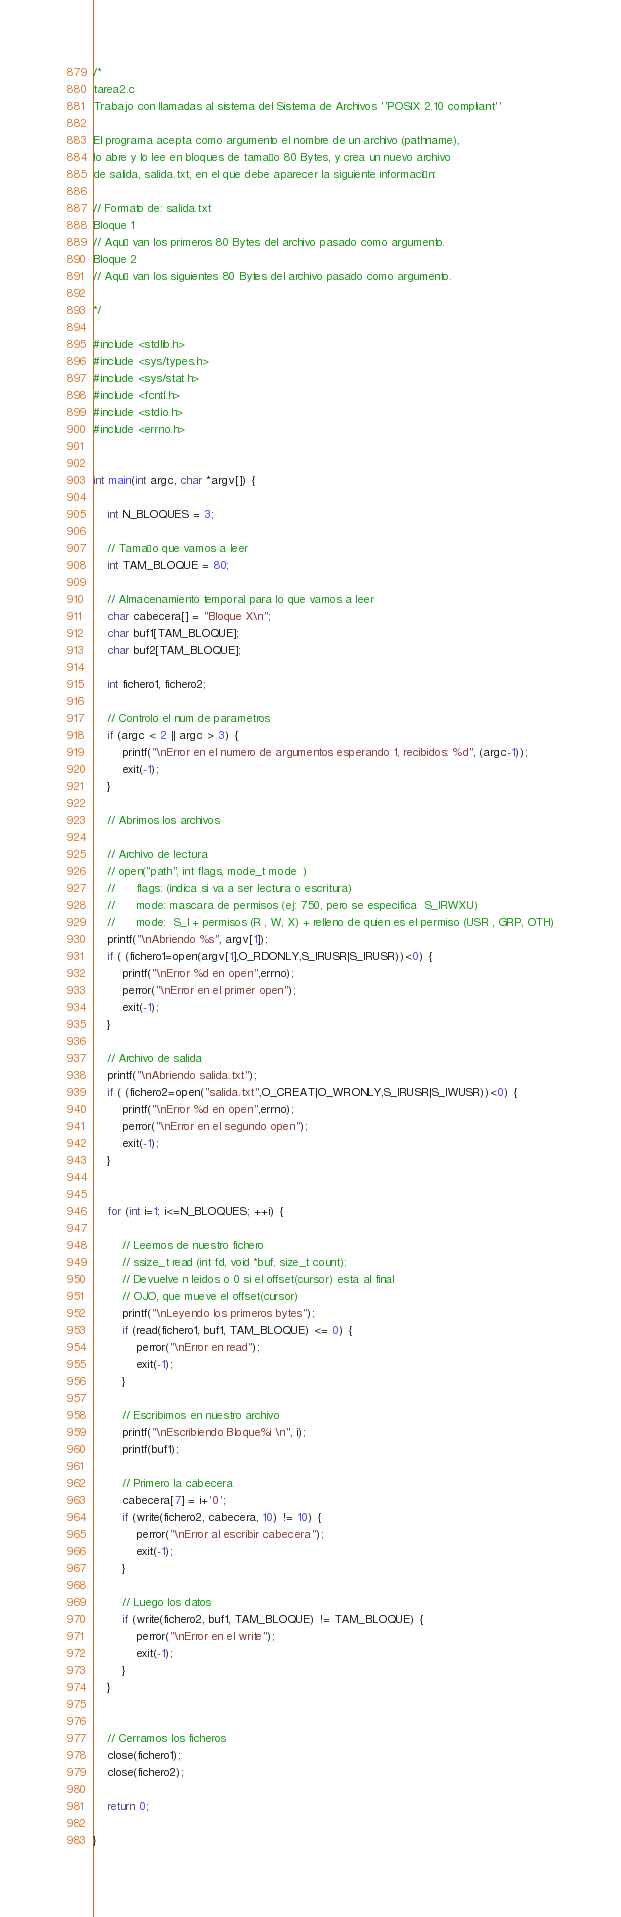<code> <loc_0><loc_0><loc_500><loc_500><_C_>/*
tarea2.c
Trabajo con llamadas al sistema del Sistema de Archivos ''POSIX 2.10 compliant''

El programa acepta como argumento el nombre de un archivo (pathname), 
lo abre y lo lee en bloques de tamaño 80 Bytes, y crea un nuevo archivo 
de salida, salida.txt, en el que debe aparecer la siguiente información:

// Formato de: salida.txt 
Bloque 1
// Aquí van los primeros 80 Bytes del archivo pasado como argumento.
Bloque 2
// Aquí van los siguientes 80 Bytes del archivo pasado como argumento.

*/

#include <stdlib.h>
#include <sys/types.h>
#include <sys/stat.h>
#include <fcntl.h>
#include <stdio.h>
#include <errno.h>


int main(int argc, char *argv[]) {
	
	int N_BLOQUES = 3;

	// Tamaño que vamos a leer
	int TAM_BLOQUE = 80;

	// Almacenamiento temporal para lo que vamos a leer
	char cabecera[] = "Bloque X\n";
	char buf1[TAM_BLOQUE];
	char buf2[TAM_BLOQUE];

	int fichero1, fichero2;

	// Controlo el num de parametros
	if (argc < 2 || argc > 3) {
		printf("\nError en el numero de argumentos esperando 1, recibidos: %d", (argc-1));
		exit(-1);
	}

	// Abrimos los archivos

	// Archivo de lectura 
	// open("path", int flags, mode_t mode  )
	// 		flags: (indica si va a ser lectura o escritura)
	// 		mode: mascara de permisos (ej: 750, pero se especifica  S_IRWXU)
	//      mode:  S_I + permisos (R , W, X) + relleno de quien es el permiso (USR , GRP, OTH)
	printf("\nAbriendo %s", argv[1]);
	if ( (fichero1=open(argv[1],O_RDONLY,S_IRUSR|S_IRUSR))<0) {
		printf("\nError %d en open",errno);
		perror("\nError en el primer open");
		exit(-1);
	}

	// Archivo de salida
	printf("\nAbriendo salida.txt");
	if ( (fichero2=open("salida.txt",O_CREAT|O_WRONLY,S_IRUSR|S_IWUSR))<0) {
		printf("\nError %d en open",errno);
		perror("\nError en el segundo open");
		exit(-1);
	}


	for (int i=1; i<=N_BLOQUES; ++i) {

		// Leemos de nuestro fichero
		// ssize_t read (int fd, void *buf, size_t count);
		// Devuelve n leidos o 0 si el offset(cursor) esta al final
		// OJO, que mueve el offset(cursor)
		printf("\nLeyendo los primeros bytes");
		if (read(fichero1, buf1, TAM_BLOQUE) <= 0) {
			perror("\nError en read");
			exit(-1);
		}

		// Escribimos en nuestro archivo
		printf("\nEscribiendo Bloque%i \n", i);
		printf(buf1);
		
		// Primero la cabecera
		cabecera[7] = i+'0';
		if (write(fichero2, cabecera, 10) != 10) {
			perror("\nError al escribir cabecera");
			exit(-1);
		}

		// Luego los datos
		if (write(fichero2, buf1, TAM_BLOQUE) != TAM_BLOQUE) {
			perror("\nError en el write");
			exit(-1);
		}	
	}


	// Cerramos los ficheros
	close(fichero1);
	close(fichero2);

	return 0;

}

</code> 